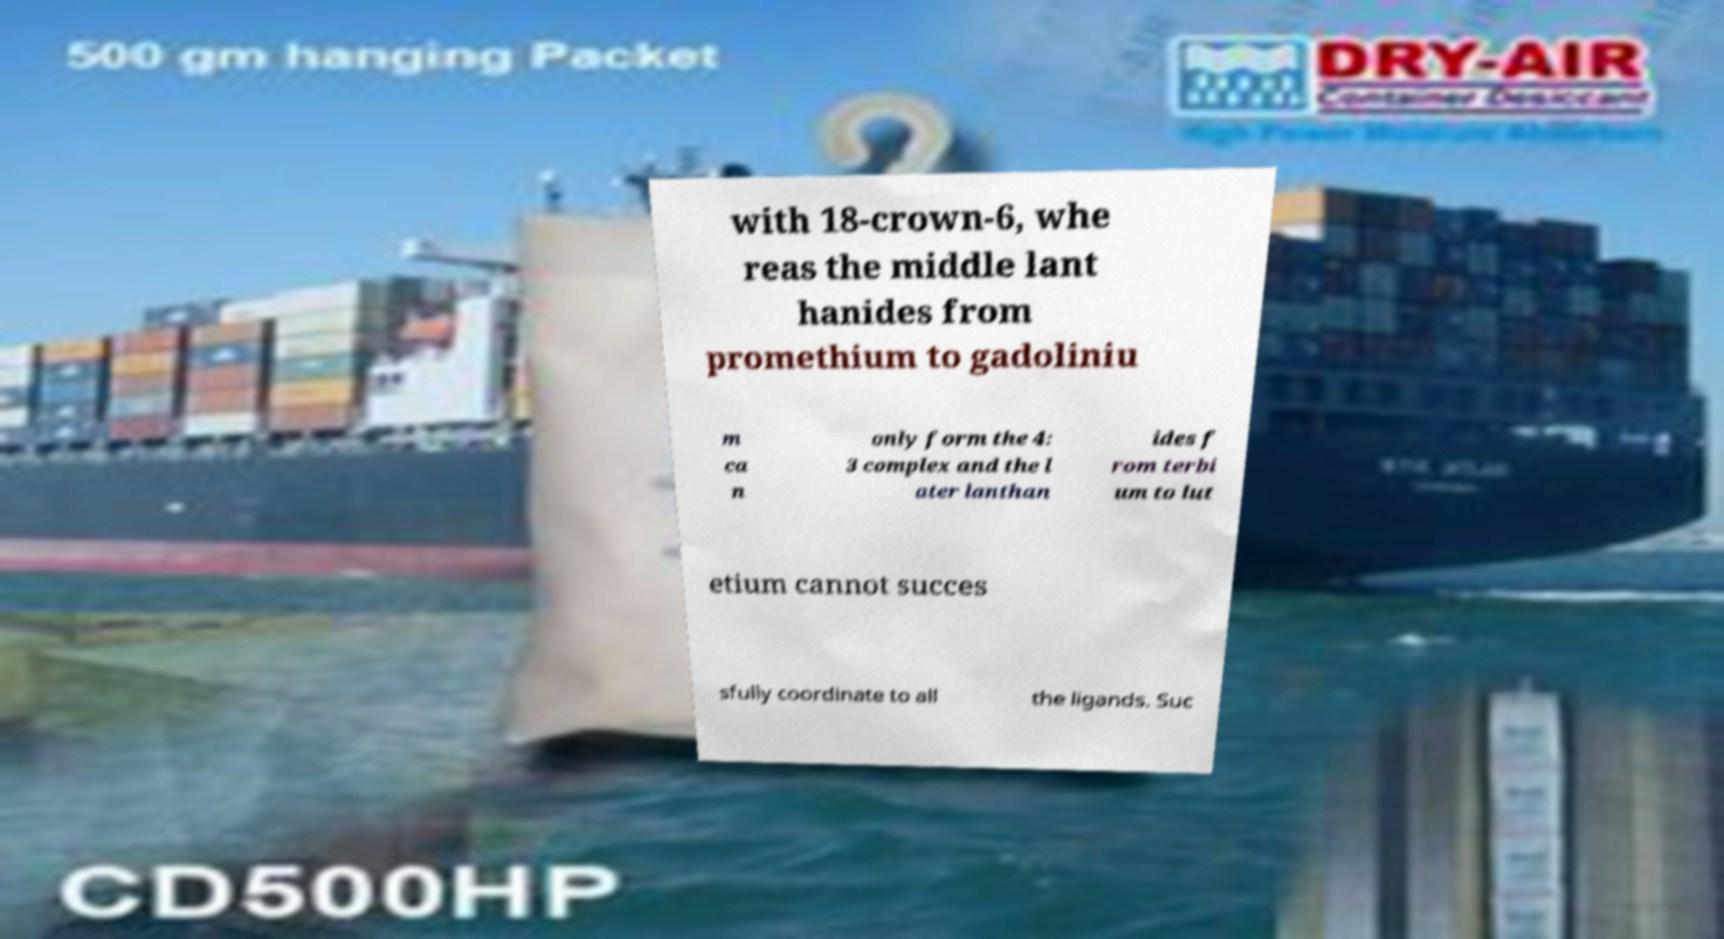Could you extract and type out the text from this image? with 18-crown-6, whe reas the middle lant hanides from promethium to gadoliniu m ca n only form the 4: 3 complex and the l ater lanthan ides f rom terbi um to lut etium cannot succes sfully coordinate to all the ligands. Suc 